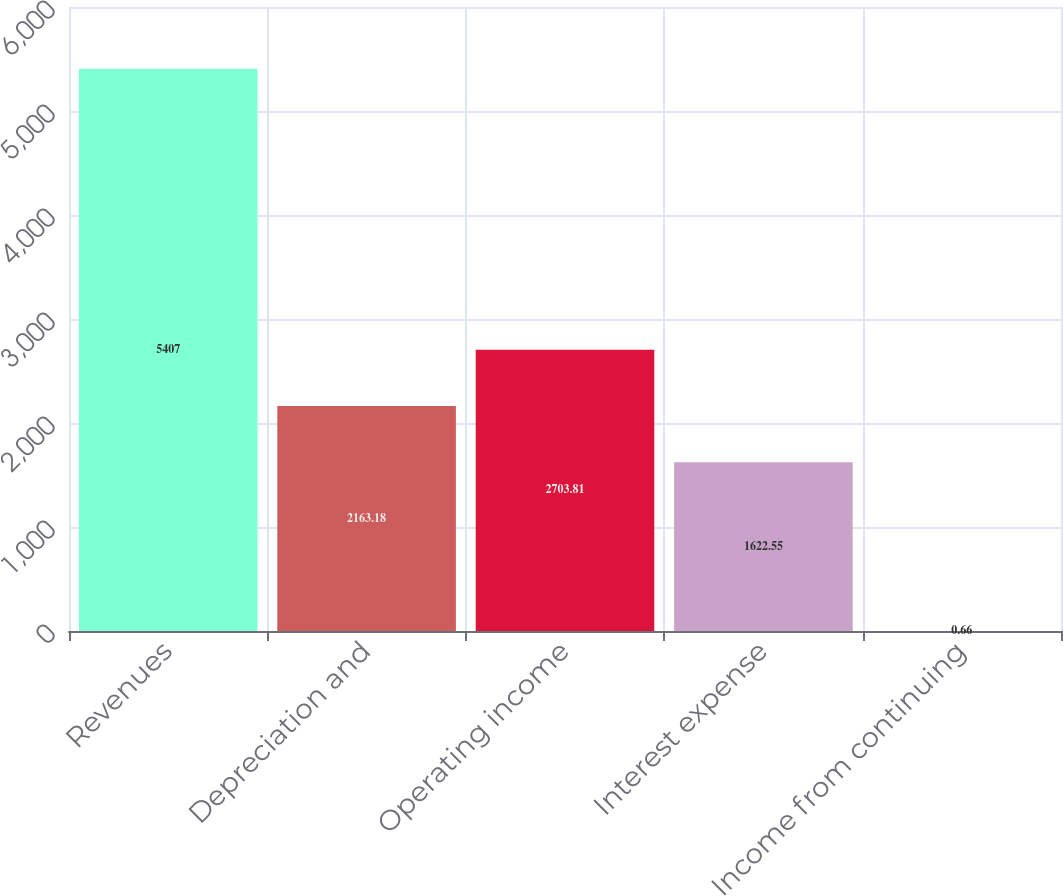Convert chart to OTSL. <chart><loc_0><loc_0><loc_500><loc_500><bar_chart><fcel>Revenues<fcel>Depreciation and<fcel>Operating income<fcel>Interest expense<fcel>Income from continuing<nl><fcel>5407<fcel>2163.18<fcel>2703.81<fcel>1622.55<fcel>0.66<nl></chart> 